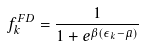Convert formula to latex. <formula><loc_0><loc_0><loc_500><loc_500>f _ { k } ^ { F D } = \frac { 1 } { 1 + e ^ { \beta ( \epsilon _ { k } - { \bar { \mu } } ) } }</formula> 